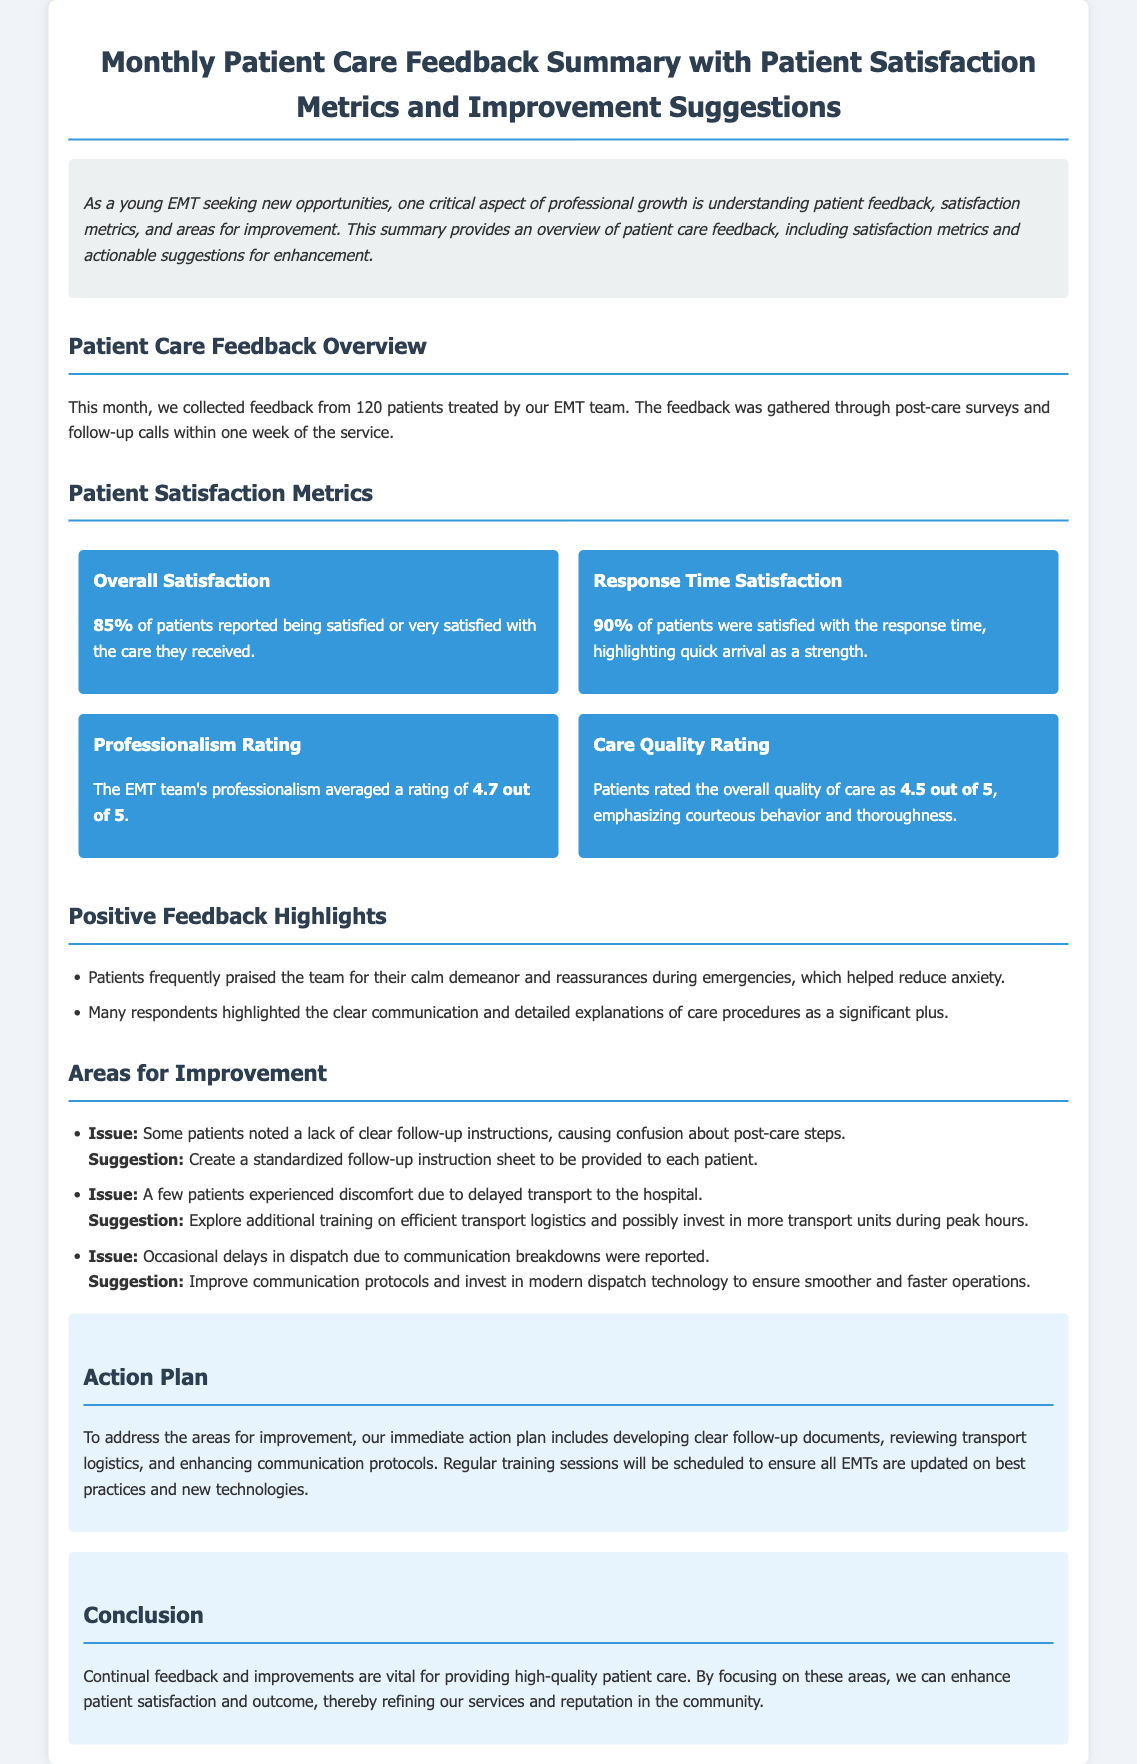what is the total number of patients surveyed? The document states that feedback was collected from 120 patients treated by the EMT team.
Answer: 120 what percentage of patients were satisfied with the care received? The document indicates that 85% of patients reported being satisfied or very satisfied with the care.
Answer: 85% what is the average professionalism rating given to the EMT team? The professionalism rating averaged a score of 4.7 out of 5.
Answer: 4.7 out of 5 what issue was noted regarding follow-up instructions? Some patients noted a lack of clear follow-up instructions, which caused confusion.
Answer: Lack of clear follow-up instructions what is one suggestion made to improve transport logistics? The document suggests exploring additional training on efficient transport logistics during peak hours.
Answer: Additional training on efficient transport logistics how many patients reported satisfaction with the response time? According to the document, 90% of patients were satisfied with the response time.
Answer: 90% what is one of the positive feedback highlights? Patients praised the team for their calm demeanor and reassurances during emergencies.
Answer: Calm demeanor and reassurances what is the recommended immediate action plan to address improvement areas? The immediate action plan includes developing clear follow-up documents and reviewing transport logistics.
Answer: Developing clear follow-up documents what was the care quality rating given by patients? Patients rated the overall quality of care as 4.5 out of 5.
Answer: 4.5 out of 5 